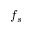<formula> <loc_0><loc_0><loc_500><loc_500>f _ { s }</formula> 